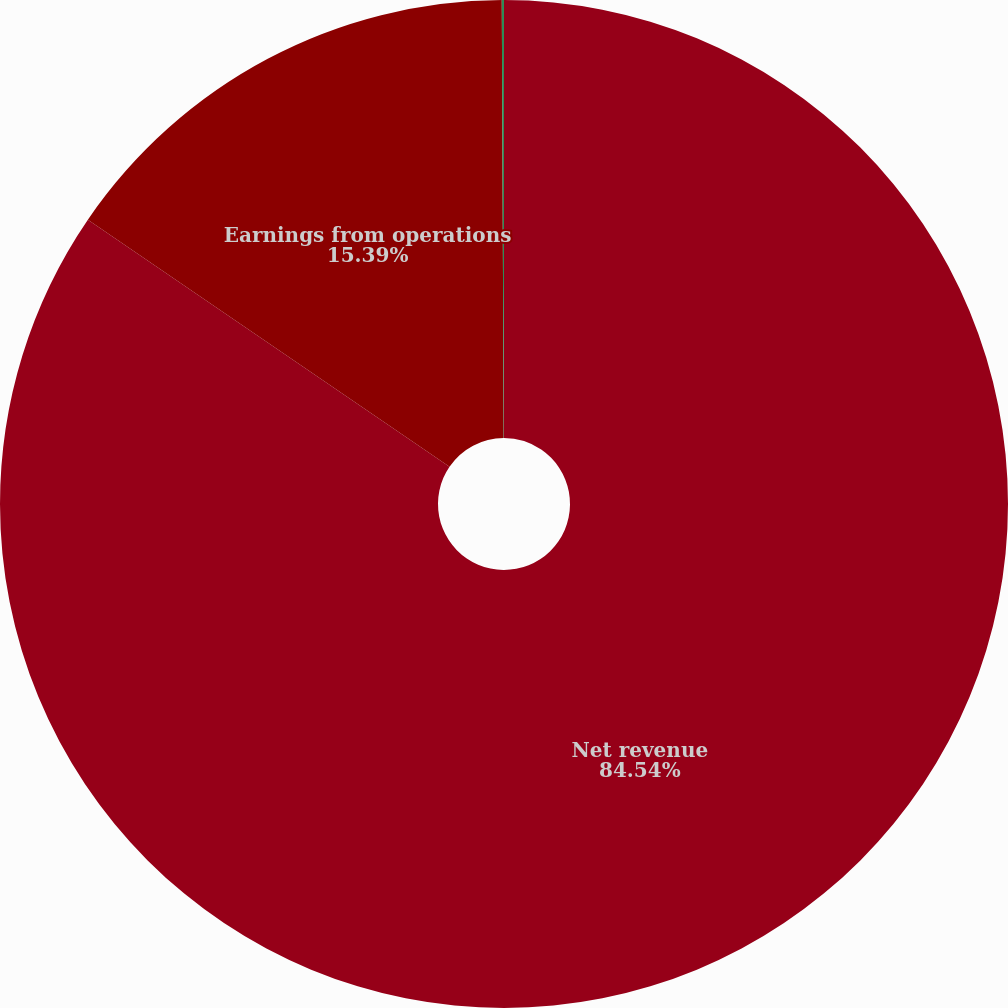Convert chart. <chart><loc_0><loc_0><loc_500><loc_500><pie_chart><fcel>Net revenue<fcel>Earnings from operations<fcel>Earnings from operations as a<nl><fcel>84.54%<fcel>15.39%<fcel>0.07%<nl></chart> 